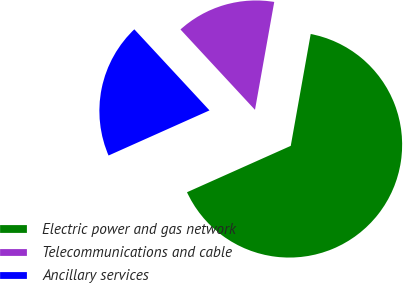<chart> <loc_0><loc_0><loc_500><loc_500><pie_chart><fcel>Electric power and gas network<fcel>Telecommunications and cable<fcel>Ancillary services<nl><fcel>65.5%<fcel>14.71%<fcel>19.79%<nl></chart> 